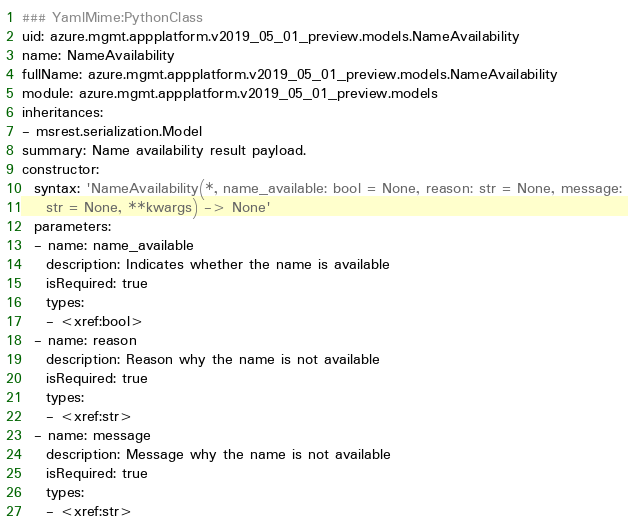<code> <loc_0><loc_0><loc_500><loc_500><_YAML_>### YamlMime:PythonClass
uid: azure.mgmt.appplatform.v2019_05_01_preview.models.NameAvailability
name: NameAvailability
fullName: azure.mgmt.appplatform.v2019_05_01_preview.models.NameAvailability
module: azure.mgmt.appplatform.v2019_05_01_preview.models
inheritances:
- msrest.serialization.Model
summary: Name availability result payload.
constructor:
  syntax: 'NameAvailability(*, name_available: bool = None, reason: str = None, message:
    str = None, **kwargs) -> None'
  parameters:
  - name: name_available
    description: Indicates whether the name is available
    isRequired: true
    types:
    - <xref:bool>
  - name: reason
    description: Reason why the name is not available
    isRequired: true
    types:
    - <xref:str>
  - name: message
    description: Message why the name is not available
    isRequired: true
    types:
    - <xref:str>
</code> 